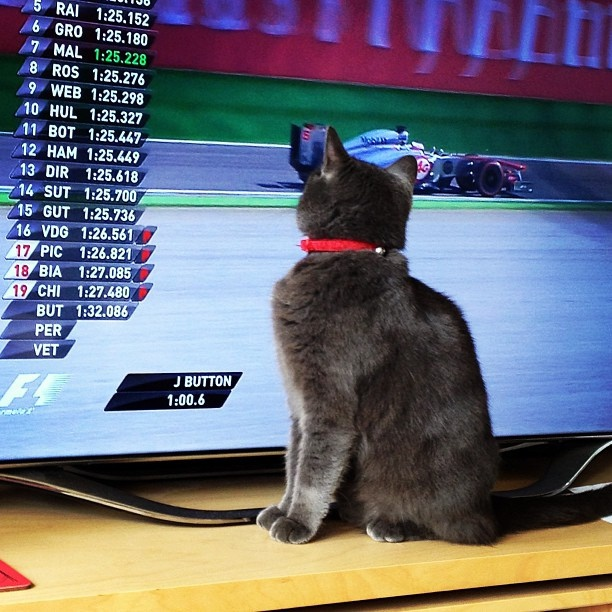Describe the objects in this image and their specific colors. I can see tv in blue, black, lightblue, and gray tones, cat in blue, black, gray, and darkgray tones, and car in blue, black, navy, and lightblue tones in this image. 